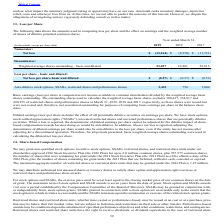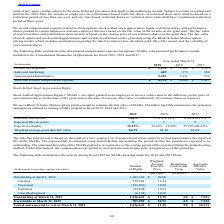According to Agilysys's financial document, What is the exercise price for stock options and SSARs? set at least equal to the closing market price of our common shares on the date of grant. The document states: "ock options and SSARs, the exercise price must be set at least equal to the closing market price of our common shares on the date of grant. The maximu..." Also, What was the Share-based Compensation for product development in 2019? According to the financial document, $1,478 (in thousands). The relevant text states: "Product development $ 1,478 $ 1,306 $ 1,545..." Also, What was the Share-based Compensation for sales and marketing in 2019? According to the financial document, 469 (in thousands). The relevant text states: "Sales and marketing 469 371 360..." Also, can you calculate: What was the increase / (decrease) in the product development Share-based Compensation from 2018 to 2019? Based on the calculation: 1,478 - 1,306, the result is 172 (in thousands). This is based on the information: "Product development $ 1,478 $ 1,306 $ 1,545 Product development $ 1,478 $ 1,306 $ 1,545..." The key data points involved are: 1,306, 1,478. Also, can you calculate: What was the average sales and marketing Share-based Compensation for 2017-2019? To answer this question, I need to perform calculations using the financial data. The calculation is: (469 + 371 + 360) / 3, which equals 400 (in thousands). This is based on the information: "Sales and marketing 469 371 360 Sales and marketing 469 371 360 Sales and marketing 469 371 360..." The key data points involved are: 360, 371, 469. Also, can you calculate: What was the average general and administrative Share-based Compensation for 2017-2019? To answer this question, I need to perform calculations using the financial data. The calculation is: (2,429 + 3,011 + 522) / 3, which equals 1987.33 (in thousands). This is based on the information: "General and administrative 2,429 3,011 522 General and administrative 2,429 3,011 522 General and administrative 2,429 3,011 522..." The key data points involved are: 2,429, 3,011, 522. 